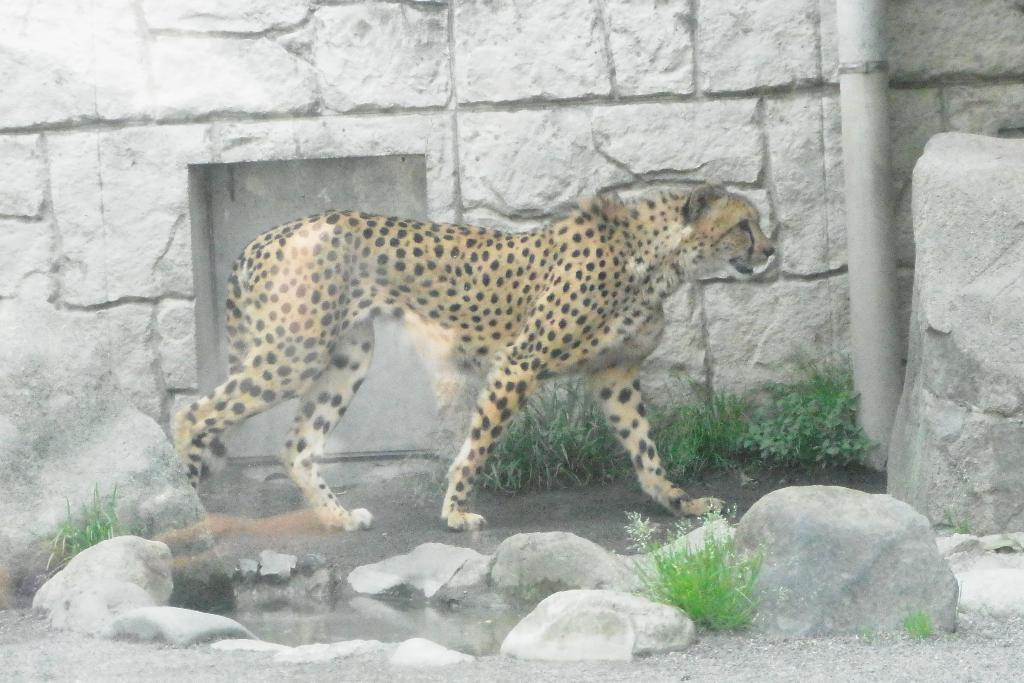What type of structure can be seen in the image? There is a wall in the image. What other living creature is present in the image? There is an animal in the image. What type of natural elements can be seen in the image? There are stones and grass in the image. How many clocks are hanging on the wall in the image? There are no clocks visible in the image; only a wall, an animal, stones, and grass can be seen. 